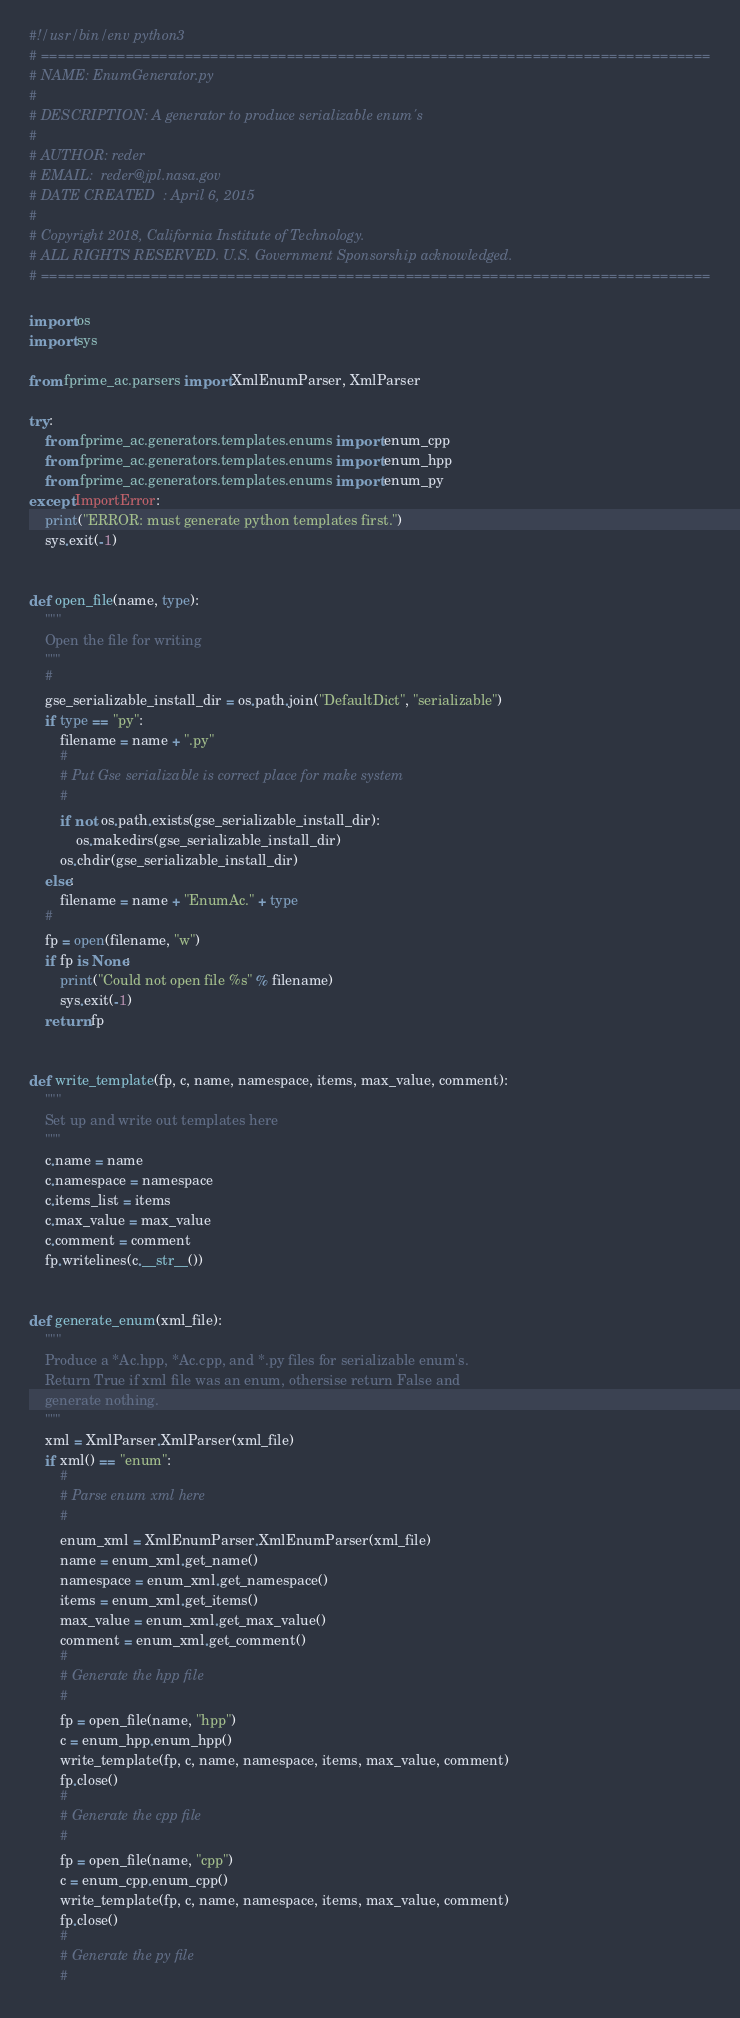<code> <loc_0><loc_0><loc_500><loc_500><_Python_>#!/usr/bin/env python3
# ===============================================================================
# NAME: EnumGenerator.py
#
# DESCRIPTION: A generator to produce serializable enum's
#
# AUTHOR: reder
# EMAIL:  reder@jpl.nasa.gov
# DATE CREATED  : April 6, 2015
#
# Copyright 2018, California Institute of Technology.
# ALL RIGHTS RESERVED. U.S. Government Sponsorship acknowledged.
# ===============================================================================

import os
import sys

from fprime_ac.parsers import XmlEnumParser, XmlParser

try:
    from fprime_ac.generators.templates.enums import enum_cpp
    from fprime_ac.generators.templates.enums import enum_hpp
    from fprime_ac.generators.templates.enums import enum_py
except ImportError:
    print("ERROR: must generate python templates first.")
    sys.exit(-1)


def open_file(name, type):
    """
    Open the file for writing
    """
    #
    gse_serializable_install_dir = os.path.join("DefaultDict", "serializable")
    if type == "py":
        filename = name + ".py"
        #
        # Put Gse serializable is correct place for make system
        #
        if not os.path.exists(gse_serializable_install_dir):
            os.makedirs(gse_serializable_install_dir)
        os.chdir(gse_serializable_install_dir)
    else:
        filename = name + "EnumAc." + type
    #
    fp = open(filename, "w")
    if fp is None:
        print("Could not open file %s" % filename)
        sys.exit(-1)
    return fp


def write_template(fp, c, name, namespace, items, max_value, comment):
    """
    Set up and write out templates here
    """
    c.name = name
    c.namespace = namespace
    c.items_list = items
    c.max_value = max_value
    c.comment = comment
    fp.writelines(c.__str__())


def generate_enum(xml_file):
    """
    Produce a *Ac.hpp, *Ac.cpp, and *.py files for serializable enum's.
    Return True if xml file was an enum, othersise return False and
    generate nothing.
    """
    xml = XmlParser.XmlParser(xml_file)
    if xml() == "enum":
        #
        # Parse enum xml here
        #
        enum_xml = XmlEnumParser.XmlEnumParser(xml_file)
        name = enum_xml.get_name()
        namespace = enum_xml.get_namespace()
        items = enum_xml.get_items()
        max_value = enum_xml.get_max_value()
        comment = enum_xml.get_comment()
        #
        # Generate the hpp file
        #
        fp = open_file(name, "hpp")
        c = enum_hpp.enum_hpp()
        write_template(fp, c, name, namespace, items, max_value, comment)
        fp.close()
        #
        # Generate the cpp file
        #
        fp = open_file(name, "cpp")
        c = enum_cpp.enum_cpp()
        write_template(fp, c, name, namespace, items, max_value, comment)
        fp.close()
        #
        # Generate the py file
        #</code> 